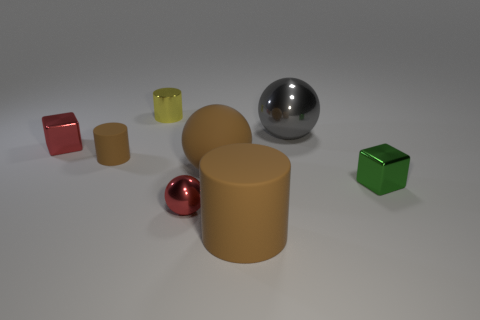How many tiny objects are cyan rubber cylinders or brown rubber cylinders?
Give a very brief answer. 1. The rubber cylinder that is the same color as the tiny matte object is what size?
Ensure brevity in your answer.  Large. Is there a small red object that has the same material as the yellow thing?
Offer a terse response. Yes. There is a gray ball that is behind the red metal ball; what is it made of?
Your response must be concise. Metal. There is a block that is left of the tiny metal ball; is its color the same as the metal ball left of the big gray metallic object?
Your answer should be compact. Yes. There is a shiny object that is the same size as the brown matte ball; what color is it?
Your answer should be compact. Gray. How many other objects are the same shape as the gray metallic thing?
Offer a very short reply. 2. There is a sphere that is behind the small red cube; how big is it?
Keep it short and to the point. Large. What number of yellow metal cylinders are behind the small cube that is right of the brown sphere?
Your answer should be compact. 1. How many other things are the same size as the yellow metallic object?
Offer a very short reply. 4. 